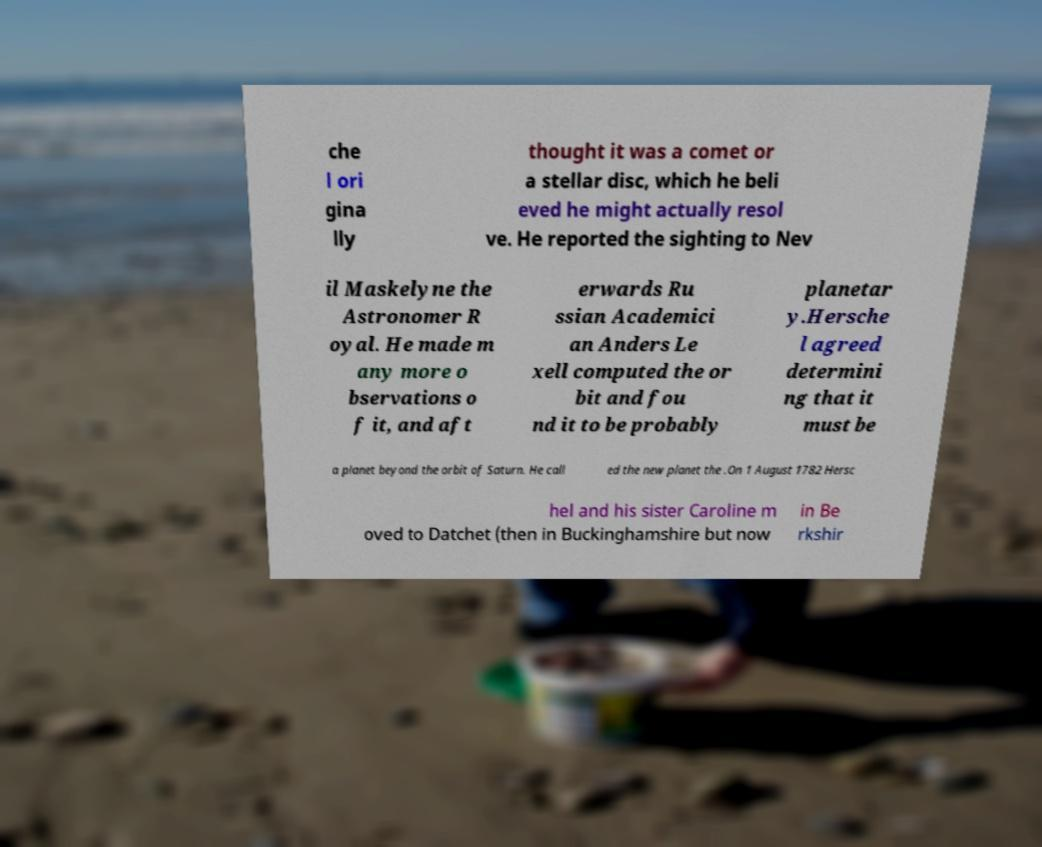Please identify and transcribe the text found in this image. che l ori gina lly thought it was a comet or a stellar disc, which he beli eved he might actually resol ve. He reported the sighting to Nev il Maskelyne the Astronomer R oyal. He made m any more o bservations o f it, and aft erwards Ru ssian Academici an Anders Le xell computed the or bit and fou nd it to be probably planetar y.Hersche l agreed determini ng that it must be a planet beyond the orbit of Saturn. He call ed the new planet the .On 1 August 1782 Hersc hel and his sister Caroline m oved to Datchet (then in Buckinghamshire but now in Be rkshir 